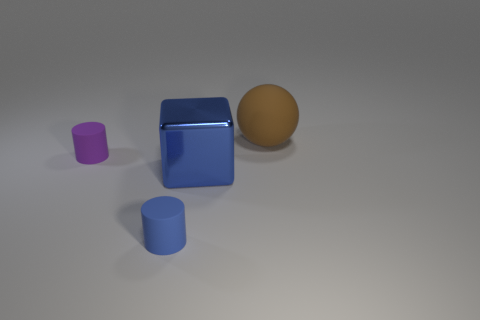The rubber ball has what color?
Your answer should be compact. Brown. Are there any other things that are the same shape as the large blue metal thing?
Give a very brief answer. No. There is another small thing that is the same shape as the purple thing; what color is it?
Keep it short and to the point. Blue. Is the metal object the same shape as the blue matte object?
Ensure brevity in your answer.  No. What number of balls are either tiny cyan objects or brown objects?
Your answer should be very brief. 1. What is the color of the sphere that is made of the same material as the small blue thing?
Your response must be concise. Brown. There is a rubber cylinder in front of the purple object; does it have the same size as the purple cylinder?
Offer a very short reply. Yes. Is the material of the large brown ball the same as the object that is in front of the metal thing?
Provide a short and direct response. Yes. There is a tiny rubber object in front of the large block; what is its color?
Offer a very short reply. Blue. There is a small thing that is to the right of the purple cylinder; is there a large brown thing that is to the left of it?
Your answer should be compact. No. 